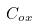<formula> <loc_0><loc_0><loc_500><loc_500>C _ { o x }</formula> 